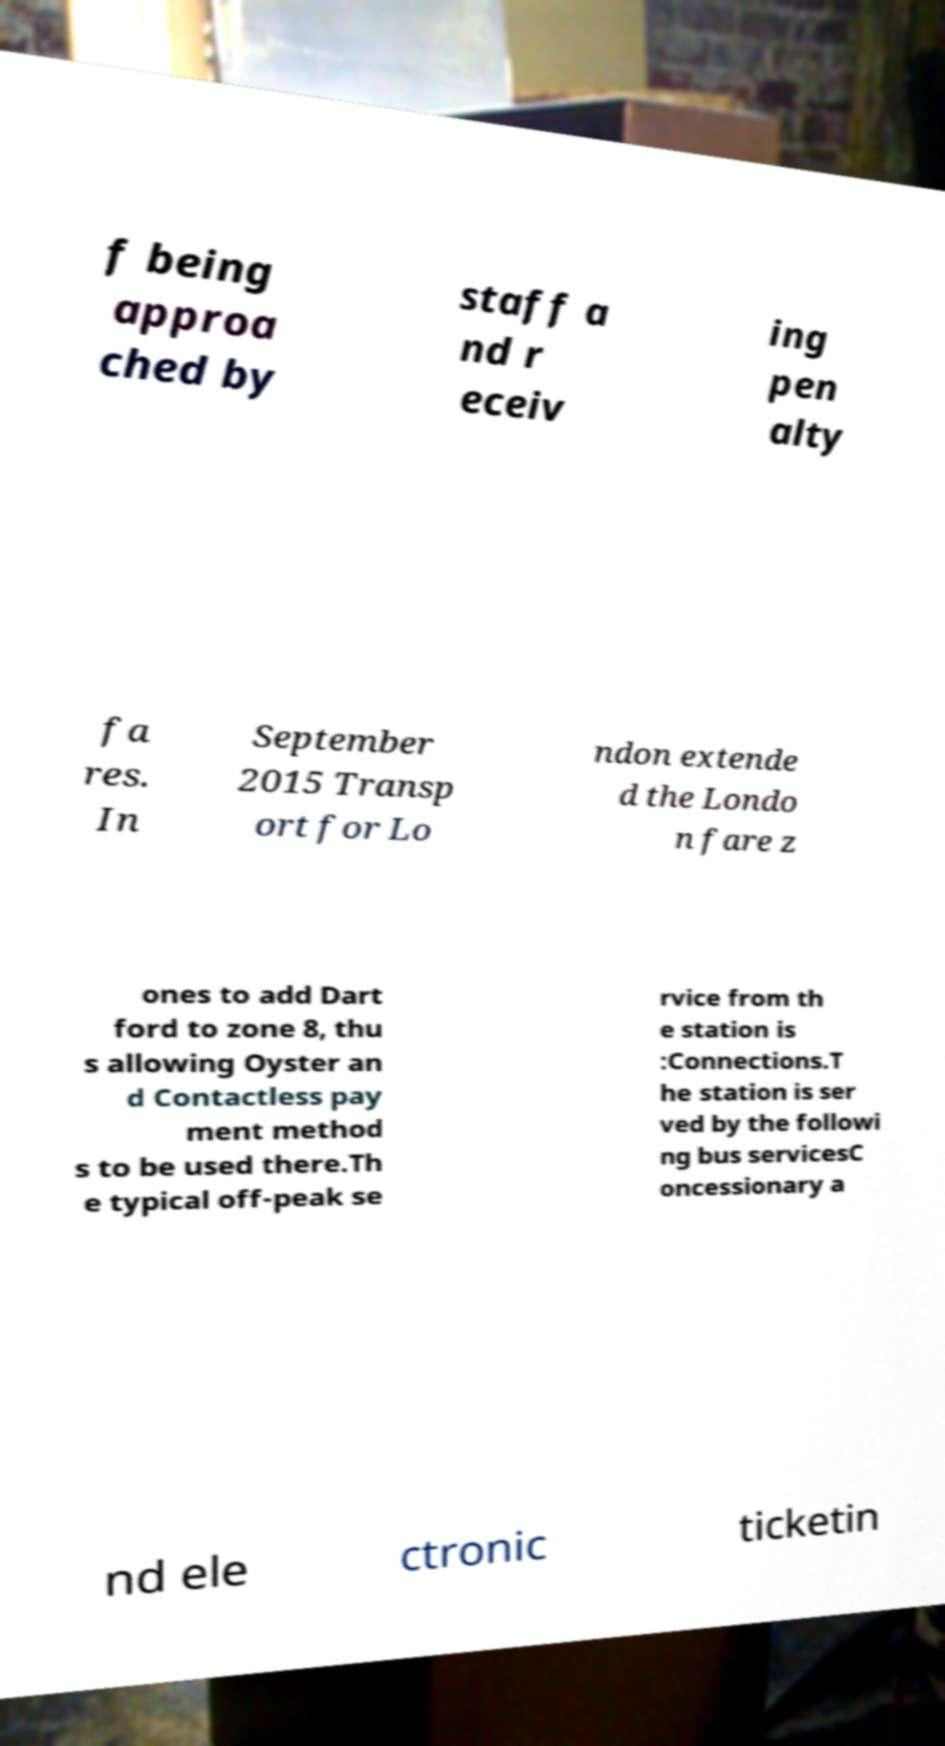Can you read and provide the text displayed in the image?This photo seems to have some interesting text. Can you extract and type it out for me? f being approa ched by staff a nd r eceiv ing pen alty fa res. In September 2015 Transp ort for Lo ndon extende d the Londo n fare z ones to add Dart ford to zone 8, thu s allowing Oyster an d Contactless pay ment method s to be used there.Th e typical off-peak se rvice from th e station is :Connections.T he station is ser ved by the followi ng bus servicesC oncessionary a nd ele ctronic ticketin 